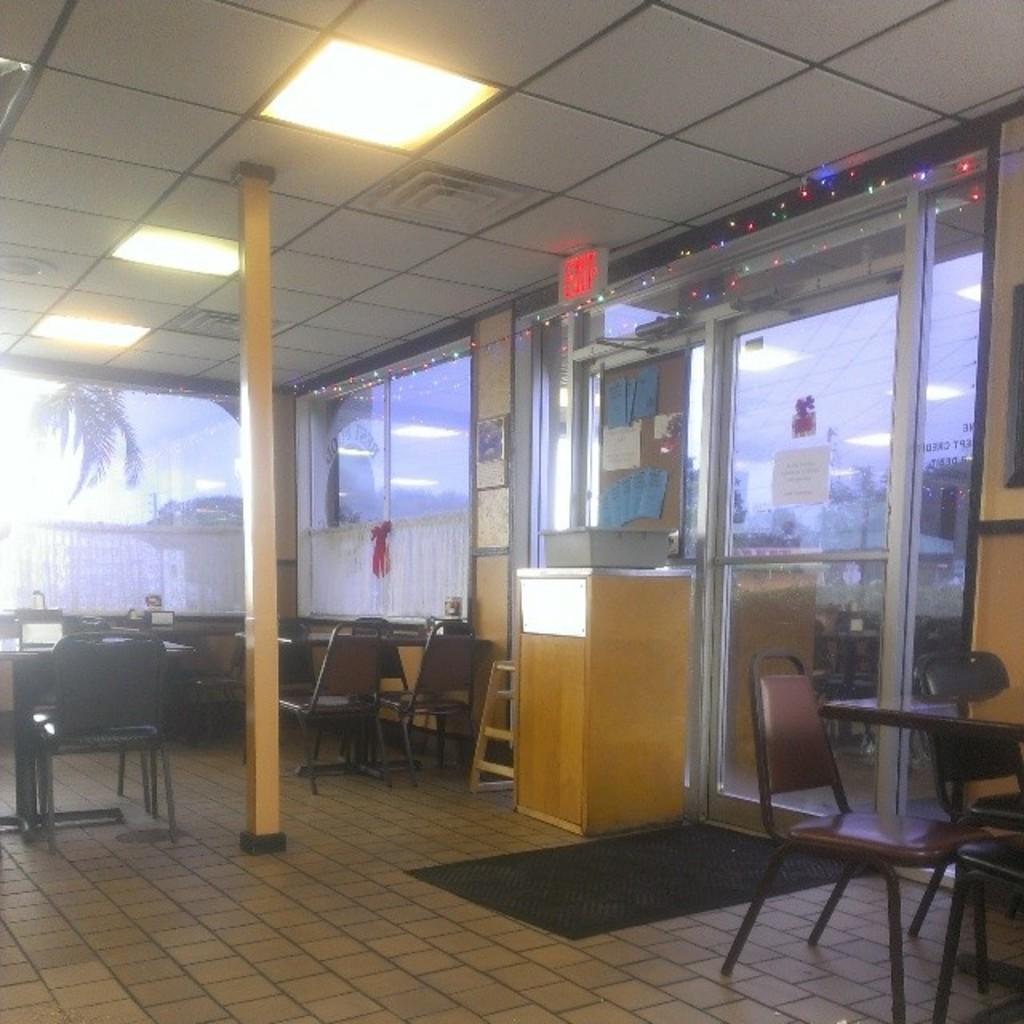In one or two sentences, can you explain what this image depicts? This picture is clicked inside the room. In the center we can see the chairs, tables and there are some objects placed on the top of the tables and we can see the roof, ceiling lights. In the background we can see the door and some papers and we can see the decoration lights and through the glass we can see the sky, trees and we can see the curtains and many other objects. 